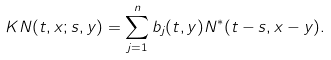<formula> <loc_0><loc_0><loc_500><loc_500>K N ( t , x ; s , y ) = \sum _ { j = 1 } ^ { n } b _ { j } ( t , y ) N ^ { * } ( t - s , x - y ) .</formula> 